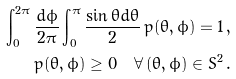<formula> <loc_0><loc_0><loc_500><loc_500>\int _ { 0 } ^ { 2 \pi } \frac { d \phi } { 2 \pi } \int _ { 0 } ^ { \pi } \frac { \sin \theta d \theta } { 2 } \, p ( \theta , \phi ) = 1 \, , \\ p ( \theta , \phi ) \geq 0 \quad \forall \, ( \theta , \phi ) \in S ^ { 2 } \, .</formula> 